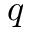Convert formula to latex. <formula><loc_0><loc_0><loc_500><loc_500>q</formula> 